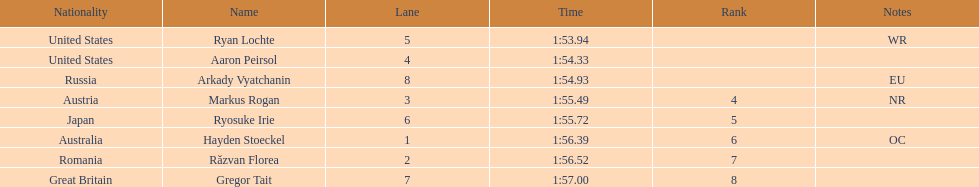Does russia or japan have the longer time? Japan. 